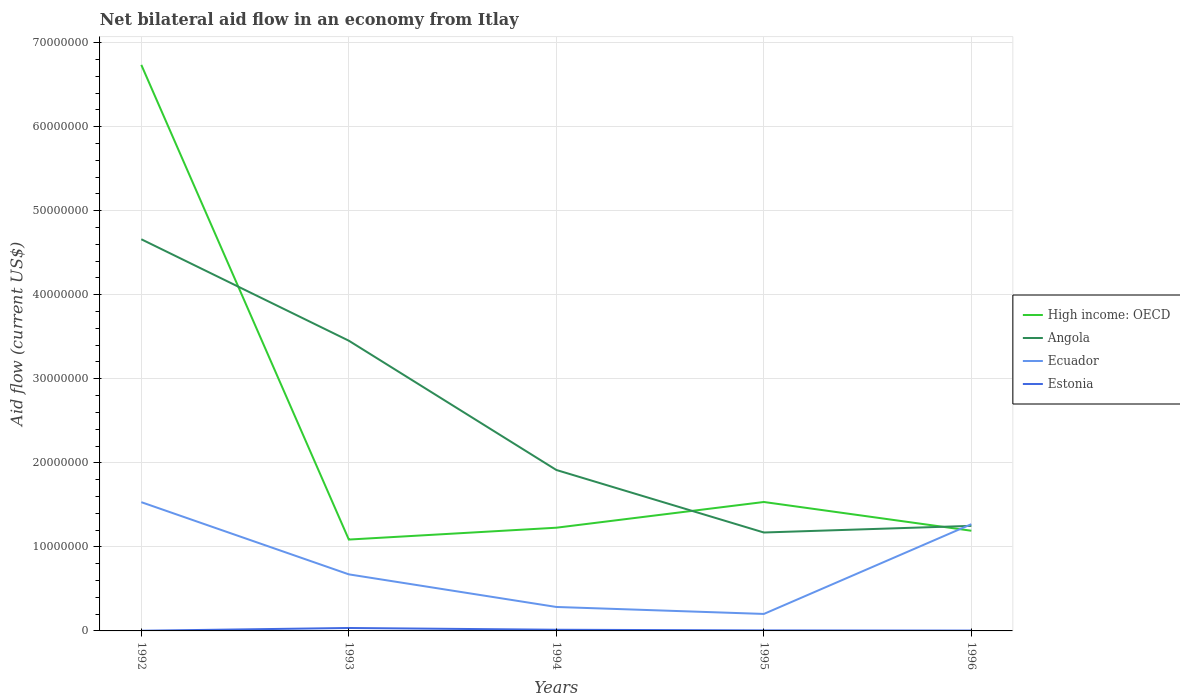How many different coloured lines are there?
Make the answer very short. 4. Is the number of lines equal to the number of legend labels?
Your answer should be very brief. Yes. In which year was the net bilateral aid flow in High income: OECD maximum?
Give a very brief answer. 1993. What is the total net bilateral aid flow in High income: OECD in the graph?
Offer a terse response. -1.05e+06. What is the difference between the highest and the second highest net bilateral aid flow in High income: OECD?
Keep it short and to the point. 5.65e+07. How many years are there in the graph?
Offer a terse response. 5. What is the difference between two consecutive major ticks on the Y-axis?
Provide a short and direct response. 1.00e+07. Are the values on the major ticks of Y-axis written in scientific E-notation?
Your response must be concise. No. Does the graph contain any zero values?
Your response must be concise. No. How many legend labels are there?
Your response must be concise. 4. What is the title of the graph?
Your answer should be compact. Net bilateral aid flow in an economy from Itlay. What is the label or title of the Y-axis?
Keep it short and to the point. Aid flow (current US$). What is the Aid flow (current US$) of High income: OECD in 1992?
Make the answer very short. 6.74e+07. What is the Aid flow (current US$) of Angola in 1992?
Keep it short and to the point. 4.66e+07. What is the Aid flow (current US$) of Ecuador in 1992?
Your response must be concise. 1.53e+07. What is the Aid flow (current US$) in Estonia in 1992?
Your answer should be compact. 2.00e+04. What is the Aid flow (current US$) in High income: OECD in 1993?
Keep it short and to the point. 1.09e+07. What is the Aid flow (current US$) of Angola in 1993?
Make the answer very short. 3.45e+07. What is the Aid flow (current US$) of Ecuador in 1993?
Make the answer very short. 6.73e+06. What is the Aid flow (current US$) in Estonia in 1993?
Make the answer very short. 3.50e+05. What is the Aid flow (current US$) in High income: OECD in 1994?
Make the answer very short. 1.23e+07. What is the Aid flow (current US$) in Angola in 1994?
Give a very brief answer. 1.92e+07. What is the Aid flow (current US$) in Ecuador in 1994?
Your answer should be compact. 2.85e+06. What is the Aid flow (current US$) in Estonia in 1994?
Provide a succinct answer. 1.40e+05. What is the Aid flow (current US$) in High income: OECD in 1995?
Your answer should be compact. 1.53e+07. What is the Aid flow (current US$) of Angola in 1995?
Provide a short and direct response. 1.17e+07. What is the Aid flow (current US$) in Ecuador in 1995?
Provide a short and direct response. 2.02e+06. What is the Aid flow (current US$) of Estonia in 1995?
Provide a short and direct response. 6.00e+04. What is the Aid flow (current US$) in High income: OECD in 1996?
Offer a very short reply. 1.19e+07. What is the Aid flow (current US$) in Angola in 1996?
Your answer should be very brief. 1.25e+07. What is the Aid flow (current US$) in Ecuador in 1996?
Provide a short and direct response. 1.27e+07. Across all years, what is the maximum Aid flow (current US$) in High income: OECD?
Offer a terse response. 6.74e+07. Across all years, what is the maximum Aid flow (current US$) of Angola?
Ensure brevity in your answer.  4.66e+07. Across all years, what is the maximum Aid flow (current US$) of Ecuador?
Make the answer very short. 1.53e+07. Across all years, what is the minimum Aid flow (current US$) of High income: OECD?
Keep it short and to the point. 1.09e+07. Across all years, what is the minimum Aid flow (current US$) in Angola?
Your answer should be very brief. 1.17e+07. Across all years, what is the minimum Aid flow (current US$) in Ecuador?
Offer a terse response. 2.02e+06. What is the total Aid flow (current US$) in High income: OECD in the graph?
Give a very brief answer. 1.18e+08. What is the total Aid flow (current US$) of Angola in the graph?
Provide a short and direct response. 1.24e+08. What is the total Aid flow (current US$) in Ecuador in the graph?
Provide a short and direct response. 3.96e+07. What is the total Aid flow (current US$) of Estonia in the graph?
Give a very brief answer. 6.10e+05. What is the difference between the Aid flow (current US$) of High income: OECD in 1992 and that in 1993?
Offer a terse response. 5.65e+07. What is the difference between the Aid flow (current US$) in Angola in 1992 and that in 1993?
Ensure brevity in your answer.  1.21e+07. What is the difference between the Aid flow (current US$) of Ecuador in 1992 and that in 1993?
Provide a succinct answer. 8.59e+06. What is the difference between the Aid flow (current US$) of Estonia in 1992 and that in 1993?
Give a very brief answer. -3.30e+05. What is the difference between the Aid flow (current US$) in High income: OECD in 1992 and that in 1994?
Your answer should be very brief. 5.51e+07. What is the difference between the Aid flow (current US$) in Angola in 1992 and that in 1994?
Offer a terse response. 2.74e+07. What is the difference between the Aid flow (current US$) in Ecuador in 1992 and that in 1994?
Keep it short and to the point. 1.25e+07. What is the difference between the Aid flow (current US$) in Estonia in 1992 and that in 1994?
Ensure brevity in your answer.  -1.20e+05. What is the difference between the Aid flow (current US$) of High income: OECD in 1992 and that in 1995?
Keep it short and to the point. 5.20e+07. What is the difference between the Aid flow (current US$) in Angola in 1992 and that in 1995?
Offer a very short reply. 3.49e+07. What is the difference between the Aid flow (current US$) in Ecuador in 1992 and that in 1995?
Keep it short and to the point. 1.33e+07. What is the difference between the Aid flow (current US$) in High income: OECD in 1992 and that in 1996?
Make the answer very short. 5.54e+07. What is the difference between the Aid flow (current US$) in Angola in 1992 and that in 1996?
Offer a terse response. 3.41e+07. What is the difference between the Aid flow (current US$) in Ecuador in 1992 and that in 1996?
Provide a succinct answer. 2.62e+06. What is the difference between the Aid flow (current US$) in High income: OECD in 1993 and that in 1994?
Provide a short and direct response. -1.41e+06. What is the difference between the Aid flow (current US$) of Angola in 1993 and that in 1994?
Your answer should be compact. 1.54e+07. What is the difference between the Aid flow (current US$) of Ecuador in 1993 and that in 1994?
Offer a terse response. 3.88e+06. What is the difference between the Aid flow (current US$) in High income: OECD in 1993 and that in 1995?
Your response must be concise. -4.47e+06. What is the difference between the Aid flow (current US$) of Angola in 1993 and that in 1995?
Provide a succinct answer. 2.28e+07. What is the difference between the Aid flow (current US$) of Ecuador in 1993 and that in 1995?
Your answer should be very brief. 4.71e+06. What is the difference between the Aid flow (current US$) of Estonia in 1993 and that in 1995?
Give a very brief answer. 2.90e+05. What is the difference between the Aid flow (current US$) of High income: OECD in 1993 and that in 1996?
Keep it short and to the point. -1.05e+06. What is the difference between the Aid flow (current US$) in Angola in 1993 and that in 1996?
Your response must be concise. 2.20e+07. What is the difference between the Aid flow (current US$) of Ecuador in 1993 and that in 1996?
Make the answer very short. -5.97e+06. What is the difference between the Aid flow (current US$) in Estonia in 1993 and that in 1996?
Make the answer very short. 3.10e+05. What is the difference between the Aid flow (current US$) of High income: OECD in 1994 and that in 1995?
Offer a terse response. -3.06e+06. What is the difference between the Aid flow (current US$) of Angola in 1994 and that in 1995?
Provide a succinct answer. 7.44e+06. What is the difference between the Aid flow (current US$) of Ecuador in 1994 and that in 1995?
Your answer should be very brief. 8.30e+05. What is the difference between the Aid flow (current US$) of High income: OECD in 1994 and that in 1996?
Keep it short and to the point. 3.60e+05. What is the difference between the Aid flow (current US$) of Angola in 1994 and that in 1996?
Offer a terse response. 6.65e+06. What is the difference between the Aid flow (current US$) in Ecuador in 1994 and that in 1996?
Your answer should be compact. -9.85e+06. What is the difference between the Aid flow (current US$) in Estonia in 1994 and that in 1996?
Provide a short and direct response. 1.00e+05. What is the difference between the Aid flow (current US$) of High income: OECD in 1995 and that in 1996?
Make the answer very short. 3.42e+06. What is the difference between the Aid flow (current US$) of Angola in 1995 and that in 1996?
Provide a short and direct response. -7.90e+05. What is the difference between the Aid flow (current US$) of Ecuador in 1995 and that in 1996?
Ensure brevity in your answer.  -1.07e+07. What is the difference between the Aid flow (current US$) of Estonia in 1995 and that in 1996?
Your response must be concise. 2.00e+04. What is the difference between the Aid flow (current US$) of High income: OECD in 1992 and the Aid flow (current US$) of Angola in 1993?
Your answer should be compact. 3.28e+07. What is the difference between the Aid flow (current US$) in High income: OECD in 1992 and the Aid flow (current US$) in Ecuador in 1993?
Give a very brief answer. 6.06e+07. What is the difference between the Aid flow (current US$) in High income: OECD in 1992 and the Aid flow (current US$) in Estonia in 1993?
Offer a very short reply. 6.70e+07. What is the difference between the Aid flow (current US$) in Angola in 1992 and the Aid flow (current US$) in Ecuador in 1993?
Provide a succinct answer. 3.99e+07. What is the difference between the Aid flow (current US$) in Angola in 1992 and the Aid flow (current US$) in Estonia in 1993?
Your answer should be compact. 4.62e+07. What is the difference between the Aid flow (current US$) of Ecuador in 1992 and the Aid flow (current US$) of Estonia in 1993?
Offer a terse response. 1.50e+07. What is the difference between the Aid flow (current US$) of High income: OECD in 1992 and the Aid flow (current US$) of Angola in 1994?
Your response must be concise. 4.82e+07. What is the difference between the Aid flow (current US$) of High income: OECD in 1992 and the Aid flow (current US$) of Ecuador in 1994?
Ensure brevity in your answer.  6.45e+07. What is the difference between the Aid flow (current US$) in High income: OECD in 1992 and the Aid flow (current US$) in Estonia in 1994?
Give a very brief answer. 6.72e+07. What is the difference between the Aid flow (current US$) in Angola in 1992 and the Aid flow (current US$) in Ecuador in 1994?
Provide a succinct answer. 4.38e+07. What is the difference between the Aid flow (current US$) in Angola in 1992 and the Aid flow (current US$) in Estonia in 1994?
Your answer should be compact. 4.65e+07. What is the difference between the Aid flow (current US$) of Ecuador in 1992 and the Aid flow (current US$) of Estonia in 1994?
Your answer should be compact. 1.52e+07. What is the difference between the Aid flow (current US$) in High income: OECD in 1992 and the Aid flow (current US$) in Angola in 1995?
Your answer should be compact. 5.56e+07. What is the difference between the Aid flow (current US$) of High income: OECD in 1992 and the Aid flow (current US$) of Ecuador in 1995?
Your response must be concise. 6.53e+07. What is the difference between the Aid flow (current US$) of High income: OECD in 1992 and the Aid flow (current US$) of Estonia in 1995?
Your response must be concise. 6.73e+07. What is the difference between the Aid flow (current US$) in Angola in 1992 and the Aid flow (current US$) in Ecuador in 1995?
Your answer should be compact. 4.46e+07. What is the difference between the Aid flow (current US$) of Angola in 1992 and the Aid flow (current US$) of Estonia in 1995?
Make the answer very short. 4.65e+07. What is the difference between the Aid flow (current US$) of Ecuador in 1992 and the Aid flow (current US$) of Estonia in 1995?
Provide a succinct answer. 1.53e+07. What is the difference between the Aid flow (current US$) of High income: OECD in 1992 and the Aid flow (current US$) of Angola in 1996?
Offer a terse response. 5.48e+07. What is the difference between the Aid flow (current US$) in High income: OECD in 1992 and the Aid flow (current US$) in Ecuador in 1996?
Offer a terse response. 5.46e+07. What is the difference between the Aid flow (current US$) of High income: OECD in 1992 and the Aid flow (current US$) of Estonia in 1996?
Ensure brevity in your answer.  6.73e+07. What is the difference between the Aid flow (current US$) of Angola in 1992 and the Aid flow (current US$) of Ecuador in 1996?
Your answer should be compact. 3.39e+07. What is the difference between the Aid flow (current US$) in Angola in 1992 and the Aid flow (current US$) in Estonia in 1996?
Offer a terse response. 4.66e+07. What is the difference between the Aid flow (current US$) in Ecuador in 1992 and the Aid flow (current US$) in Estonia in 1996?
Offer a terse response. 1.53e+07. What is the difference between the Aid flow (current US$) of High income: OECD in 1993 and the Aid flow (current US$) of Angola in 1994?
Offer a very short reply. -8.28e+06. What is the difference between the Aid flow (current US$) of High income: OECD in 1993 and the Aid flow (current US$) of Ecuador in 1994?
Your response must be concise. 8.02e+06. What is the difference between the Aid flow (current US$) in High income: OECD in 1993 and the Aid flow (current US$) in Estonia in 1994?
Your answer should be very brief. 1.07e+07. What is the difference between the Aid flow (current US$) of Angola in 1993 and the Aid flow (current US$) of Ecuador in 1994?
Ensure brevity in your answer.  3.17e+07. What is the difference between the Aid flow (current US$) in Angola in 1993 and the Aid flow (current US$) in Estonia in 1994?
Your response must be concise. 3.44e+07. What is the difference between the Aid flow (current US$) of Ecuador in 1993 and the Aid flow (current US$) of Estonia in 1994?
Provide a succinct answer. 6.59e+06. What is the difference between the Aid flow (current US$) of High income: OECD in 1993 and the Aid flow (current US$) of Angola in 1995?
Offer a very short reply. -8.40e+05. What is the difference between the Aid flow (current US$) in High income: OECD in 1993 and the Aid flow (current US$) in Ecuador in 1995?
Provide a short and direct response. 8.85e+06. What is the difference between the Aid flow (current US$) in High income: OECD in 1993 and the Aid flow (current US$) in Estonia in 1995?
Provide a succinct answer. 1.08e+07. What is the difference between the Aid flow (current US$) of Angola in 1993 and the Aid flow (current US$) of Ecuador in 1995?
Provide a succinct answer. 3.25e+07. What is the difference between the Aid flow (current US$) of Angola in 1993 and the Aid flow (current US$) of Estonia in 1995?
Keep it short and to the point. 3.45e+07. What is the difference between the Aid flow (current US$) in Ecuador in 1993 and the Aid flow (current US$) in Estonia in 1995?
Provide a short and direct response. 6.67e+06. What is the difference between the Aid flow (current US$) in High income: OECD in 1993 and the Aid flow (current US$) in Angola in 1996?
Your answer should be compact. -1.63e+06. What is the difference between the Aid flow (current US$) of High income: OECD in 1993 and the Aid flow (current US$) of Ecuador in 1996?
Offer a very short reply. -1.83e+06. What is the difference between the Aid flow (current US$) in High income: OECD in 1993 and the Aid flow (current US$) in Estonia in 1996?
Your answer should be compact. 1.08e+07. What is the difference between the Aid flow (current US$) of Angola in 1993 and the Aid flow (current US$) of Ecuador in 1996?
Your answer should be very brief. 2.18e+07. What is the difference between the Aid flow (current US$) in Angola in 1993 and the Aid flow (current US$) in Estonia in 1996?
Provide a succinct answer. 3.45e+07. What is the difference between the Aid flow (current US$) of Ecuador in 1993 and the Aid flow (current US$) of Estonia in 1996?
Your answer should be compact. 6.69e+06. What is the difference between the Aid flow (current US$) in High income: OECD in 1994 and the Aid flow (current US$) in Angola in 1995?
Offer a terse response. 5.70e+05. What is the difference between the Aid flow (current US$) in High income: OECD in 1994 and the Aid flow (current US$) in Ecuador in 1995?
Give a very brief answer. 1.03e+07. What is the difference between the Aid flow (current US$) of High income: OECD in 1994 and the Aid flow (current US$) of Estonia in 1995?
Offer a terse response. 1.22e+07. What is the difference between the Aid flow (current US$) of Angola in 1994 and the Aid flow (current US$) of Ecuador in 1995?
Provide a short and direct response. 1.71e+07. What is the difference between the Aid flow (current US$) in Angola in 1994 and the Aid flow (current US$) in Estonia in 1995?
Offer a terse response. 1.91e+07. What is the difference between the Aid flow (current US$) in Ecuador in 1994 and the Aid flow (current US$) in Estonia in 1995?
Make the answer very short. 2.79e+06. What is the difference between the Aid flow (current US$) of High income: OECD in 1994 and the Aid flow (current US$) of Angola in 1996?
Your response must be concise. -2.20e+05. What is the difference between the Aid flow (current US$) in High income: OECD in 1994 and the Aid flow (current US$) in Ecuador in 1996?
Give a very brief answer. -4.20e+05. What is the difference between the Aid flow (current US$) of High income: OECD in 1994 and the Aid flow (current US$) of Estonia in 1996?
Your response must be concise. 1.22e+07. What is the difference between the Aid flow (current US$) of Angola in 1994 and the Aid flow (current US$) of Ecuador in 1996?
Provide a succinct answer. 6.45e+06. What is the difference between the Aid flow (current US$) in Angola in 1994 and the Aid flow (current US$) in Estonia in 1996?
Provide a short and direct response. 1.91e+07. What is the difference between the Aid flow (current US$) in Ecuador in 1994 and the Aid flow (current US$) in Estonia in 1996?
Provide a succinct answer. 2.81e+06. What is the difference between the Aid flow (current US$) in High income: OECD in 1995 and the Aid flow (current US$) in Angola in 1996?
Your answer should be very brief. 2.84e+06. What is the difference between the Aid flow (current US$) of High income: OECD in 1995 and the Aid flow (current US$) of Ecuador in 1996?
Provide a succinct answer. 2.64e+06. What is the difference between the Aid flow (current US$) of High income: OECD in 1995 and the Aid flow (current US$) of Estonia in 1996?
Keep it short and to the point. 1.53e+07. What is the difference between the Aid flow (current US$) in Angola in 1995 and the Aid flow (current US$) in Ecuador in 1996?
Give a very brief answer. -9.90e+05. What is the difference between the Aid flow (current US$) of Angola in 1995 and the Aid flow (current US$) of Estonia in 1996?
Your response must be concise. 1.17e+07. What is the difference between the Aid flow (current US$) of Ecuador in 1995 and the Aid flow (current US$) of Estonia in 1996?
Provide a succinct answer. 1.98e+06. What is the average Aid flow (current US$) in High income: OECD per year?
Your answer should be compact. 2.36e+07. What is the average Aid flow (current US$) in Angola per year?
Your response must be concise. 2.49e+07. What is the average Aid flow (current US$) in Ecuador per year?
Give a very brief answer. 7.92e+06. What is the average Aid flow (current US$) in Estonia per year?
Your answer should be compact. 1.22e+05. In the year 1992, what is the difference between the Aid flow (current US$) in High income: OECD and Aid flow (current US$) in Angola?
Your answer should be compact. 2.08e+07. In the year 1992, what is the difference between the Aid flow (current US$) of High income: OECD and Aid flow (current US$) of Ecuador?
Your answer should be compact. 5.20e+07. In the year 1992, what is the difference between the Aid flow (current US$) in High income: OECD and Aid flow (current US$) in Estonia?
Your answer should be compact. 6.73e+07. In the year 1992, what is the difference between the Aid flow (current US$) of Angola and Aid flow (current US$) of Ecuador?
Your answer should be very brief. 3.13e+07. In the year 1992, what is the difference between the Aid flow (current US$) of Angola and Aid flow (current US$) of Estonia?
Your answer should be very brief. 4.66e+07. In the year 1992, what is the difference between the Aid flow (current US$) in Ecuador and Aid flow (current US$) in Estonia?
Your answer should be very brief. 1.53e+07. In the year 1993, what is the difference between the Aid flow (current US$) of High income: OECD and Aid flow (current US$) of Angola?
Offer a terse response. -2.37e+07. In the year 1993, what is the difference between the Aid flow (current US$) in High income: OECD and Aid flow (current US$) in Ecuador?
Offer a terse response. 4.14e+06. In the year 1993, what is the difference between the Aid flow (current US$) in High income: OECD and Aid flow (current US$) in Estonia?
Offer a very short reply. 1.05e+07. In the year 1993, what is the difference between the Aid flow (current US$) in Angola and Aid flow (current US$) in Ecuador?
Offer a terse response. 2.78e+07. In the year 1993, what is the difference between the Aid flow (current US$) of Angola and Aid flow (current US$) of Estonia?
Ensure brevity in your answer.  3.42e+07. In the year 1993, what is the difference between the Aid flow (current US$) of Ecuador and Aid flow (current US$) of Estonia?
Your response must be concise. 6.38e+06. In the year 1994, what is the difference between the Aid flow (current US$) in High income: OECD and Aid flow (current US$) in Angola?
Provide a short and direct response. -6.87e+06. In the year 1994, what is the difference between the Aid flow (current US$) of High income: OECD and Aid flow (current US$) of Ecuador?
Your answer should be compact. 9.43e+06. In the year 1994, what is the difference between the Aid flow (current US$) in High income: OECD and Aid flow (current US$) in Estonia?
Ensure brevity in your answer.  1.21e+07. In the year 1994, what is the difference between the Aid flow (current US$) of Angola and Aid flow (current US$) of Ecuador?
Your answer should be compact. 1.63e+07. In the year 1994, what is the difference between the Aid flow (current US$) of Angola and Aid flow (current US$) of Estonia?
Make the answer very short. 1.90e+07. In the year 1994, what is the difference between the Aid flow (current US$) in Ecuador and Aid flow (current US$) in Estonia?
Make the answer very short. 2.71e+06. In the year 1995, what is the difference between the Aid flow (current US$) in High income: OECD and Aid flow (current US$) in Angola?
Offer a very short reply. 3.63e+06. In the year 1995, what is the difference between the Aid flow (current US$) in High income: OECD and Aid flow (current US$) in Ecuador?
Provide a succinct answer. 1.33e+07. In the year 1995, what is the difference between the Aid flow (current US$) of High income: OECD and Aid flow (current US$) of Estonia?
Make the answer very short. 1.53e+07. In the year 1995, what is the difference between the Aid flow (current US$) of Angola and Aid flow (current US$) of Ecuador?
Keep it short and to the point. 9.69e+06. In the year 1995, what is the difference between the Aid flow (current US$) of Angola and Aid flow (current US$) of Estonia?
Your answer should be very brief. 1.16e+07. In the year 1995, what is the difference between the Aid flow (current US$) in Ecuador and Aid flow (current US$) in Estonia?
Offer a terse response. 1.96e+06. In the year 1996, what is the difference between the Aid flow (current US$) in High income: OECD and Aid flow (current US$) in Angola?
Offer a very short reply. -5.80e+05. In the year 1996, what is the difference between the Aid flow (current US$) in High income: OECD and Aid flow (current US$) in Ecuador?
Your answer should be very brief. -7.80e+05. In the year 1996, what is the difference between the Aid flow (current US$) in High income: OECD and Aid flow (current US$) in Estonia?
Provide a short and direct response. 1.19e+07. In the year 1996, what is the difference between the Aid flow (current US$) in Angola and Aid flow (current US$) in Estonia?
Ensure brevity in your answer.  1.25e+07. In the year 1996, what is the difference between the Aid flow (current US$) of Ecuador and Aid flow (current US$) of Estonia?
Your answer should be very brief. 1.27e+07. What is the ratio of the Aid flow (current US$) of High income: OECD in 1992 to that in 1993?
Offer a terse response. 6.2. What is the ratio of the Aid flow (current US$) in Angola in 1992 to that in 1993?
Provide a succinct answer. 1.35. What is the ratio of the Aid flow (current US$) of Ecuador in 1992 to that in 1993?
Keep it short and to the point. 2.28. What is the ratio of the Aid flow (current US$) in Estonia in 1992 to that in 1993?
Make the answer very short. 0.06. What is the ratio of the Aid flow (current US$) of High income: OECD in 1992 to that in 1994?
Offer a terse response. 5.48. What is the ratio of the Aid flow (current US$) in Angola in 1992 to that in 1994?
Your answer should be compact. 2.43. What is the ratio of the Aid flow (current US$) in Ecuador in 1992 to that in 1994?
Your answer should be very brief. 5.38. What is the ratio of the Aid flow (current US$) of Estonia in 1992 to that in 1994?
Ensure brevity in your answer.  0.14. What is the ratio of the Aid flow (current US$) in High income: OECD in 1992 to that in 1995?
Make the answer very short. 4.39. What is the ratio of the Aid flow (current US$) of Angola in 1992 to that in 1995?
Ensure brevity in your answer.  3.98. What is the ratio of the Aid flow (current US$) in Ecuador in 1992 to that in 1995?
Give a very brief answer. 7.58. What is the ratio of the Aid flow (current US$) of Estonia in 1992 to that in 1995?
Your answer should be compact. 0.33. What is the ratio of the Aid flow (current US$) of High income: OECD in 1992 to that in 1996?
Offer a terse response. 5.65. What is the ratio of the Aid flow (current US$) in Angola in 1992 to that in 1996?
Give a very brief answer. 3.73. What is the ratio of the Aid flow (current US$) in Ecuador in 1992 to that in 1996?
Provide a succinct answer. 1.21. What is the ratio of the Aid flow (current US$) in Estonia in 1992 to that in 1996?
Make the answer very short. 0.5. What is the ratio of the Aid flow (current US$) of High income: OECD in 1993 to that in 1994?
Make the answer very short. 0.89. What is the ratio of the Aid flow (current US$) of Angola in 1993 to that in 1994?
Give a very brief answer. 1.8. What is the ratio of the Aid flow (current US$) in Ecuador in 1993 to that in 1994?
Offer a terse response. 2.36. What is the ratio of the Aid flow (current US$) in High income: OECD in 1993 to that in 1995?
Keep it short and to the point. 0.71. What is the ratio of the Aid flow (current US$) of Angola in 1993 to that in 1995?
Provide a short and direct response. 2.95. What is the ratio of the Aid flow (current US$) of Ecuador in 1993 to that in 1995?
Your response must be concise. 3.33. What is the ratio of the Aid flow (current US$) in Estonia in 1993 to that in 1995?
Ensure brevity in your answer.  5.83. What is the ratio of the Aid flow (current US$) of High income: OECD in 1993 to that in 1996?
Your answer should be very brief. 0.91. What is the ratio of the Aid flow (current US$) of Angola in 1993 to that in 1996?
Ensure brevity in your answer.  2.76. What is the ratio of the Aid flow (current US$) in Ecuador in 1993 to that in 1996?
Ensure brevity in your answer.  0.53. What is the ratio of the Aid flow (current US$) of Estonia in 1993 to that in 1996?
Provide a short and direct response. 8.75. What is the ratio of the Aid flow (current US$) in High income: OECD in 1994 to that in 1995?
Your answer should be compact. 0.8. What is the ratio of the Aid flow (current US$) of Angola in 1994 to that in 1995?
Ensure brevity in your answer.  1.64. What is the ratio of the Aid flow (current US$) in Ecuador in 1994 to that in 1995?
Provide a succinct answer. 1.41. What is the ratio of the Aid flow (current US$) in Estonia in 1994 to that in 1995?
Your response must be concise. 2.33. What is the ratio of the Aid flow (current US$) of High income: OECD in 1994 to that in 1996?
Offer a very short reply. 1.03. What is the ratio of the Aid flow (current US$) of Angola in 1994 to that in 1996?
Your answer should be very brief. 1.53. What is the ratio of the Aid flow (current US$) of Ecuador in 1994 to that in 1996?
Your response must be concise. 0.22. What is the ratio of the Aid flow (current US$) in Estonia in 1994 to that in 1996?
Your response must be concise. 3.5. What is the ratio of the Aid flow (current US$) of High income: OECD in 1995 to that in 1996?
Make the answer very short. 1.29. What is the ratio of the Aid flow (current US$) of Angola in 1995 to that in 1996?
Offer a very short reply. 0.94. What is the ratio of the Aid flow (current US$) in Ecuador in 1995 to that in 1996?
Your answer should be compact. 0.16. What is the ratio of the Aid flow (current US$) of Estonia in 1995 to that in 1996?
Provide a succinct answer. 1.5. What is the difference between the highest and the second highest Aid flow (current US$) in High income: OECD?
Your answer should be compact. 5.20e+07. What is the difference between the highest and the second highest Aid flow (current US$) in Angola?
Your answer should be very brief. 1.21e+07. What is the difference between the highest and the second highest Aid flow (current US$) of Ecuador?
Your answer should be very brief. 2.62e+06. What is the difference between the highest and the lowest Aid flow (current US$) in High income: OECD?
Offer a very short reply. 5.65e+07. What is the difference between the highest and the lowest Aid flow (current US$) in Angola?
Keep it short and to the point. 3.49e+07. What is the difference between the highest and the lowest Aid flow (current US$) of Ecuador?
Your response must be concise. 1.33e+07. 